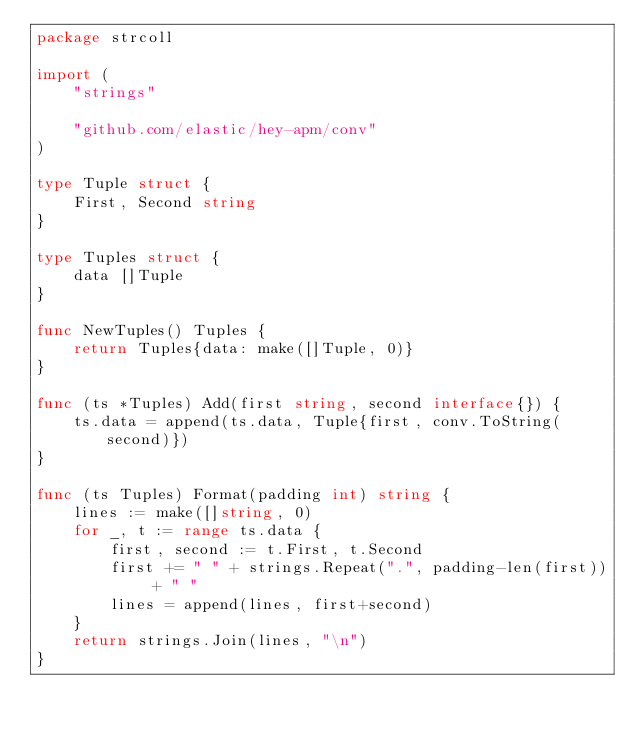Convert code to text. <code><loc_0><loc_0><loc_500><loc_500><_Go_>package strcoll

import (
	"strings"

	"github.com/elastic/hey-apm/conv"
)

type Tuple struct {
	First, Second string
}

type Tuples struct {
	data []Tuple
}

func NewTuples() Tuples {
	return Tuples{data: make([]Tuple, 0)}
}

func (ts *Tuples) Add(first string, second interface{}) {
	ts.data = append(ts.data, Tuple{first, conv.ToString(second)})
}

func (ts Tuples) Format(padding int) string {
	lines := make([]string, 0)
	for _, t := range ts.data {
		first, second := t.First, t.Second
		first += " " + strings.Repeat(".", padding-len(first)) + " "
		lines = append(lines, first+second)
	}
	return strings.Join(lines, "\n")
}
</code> 